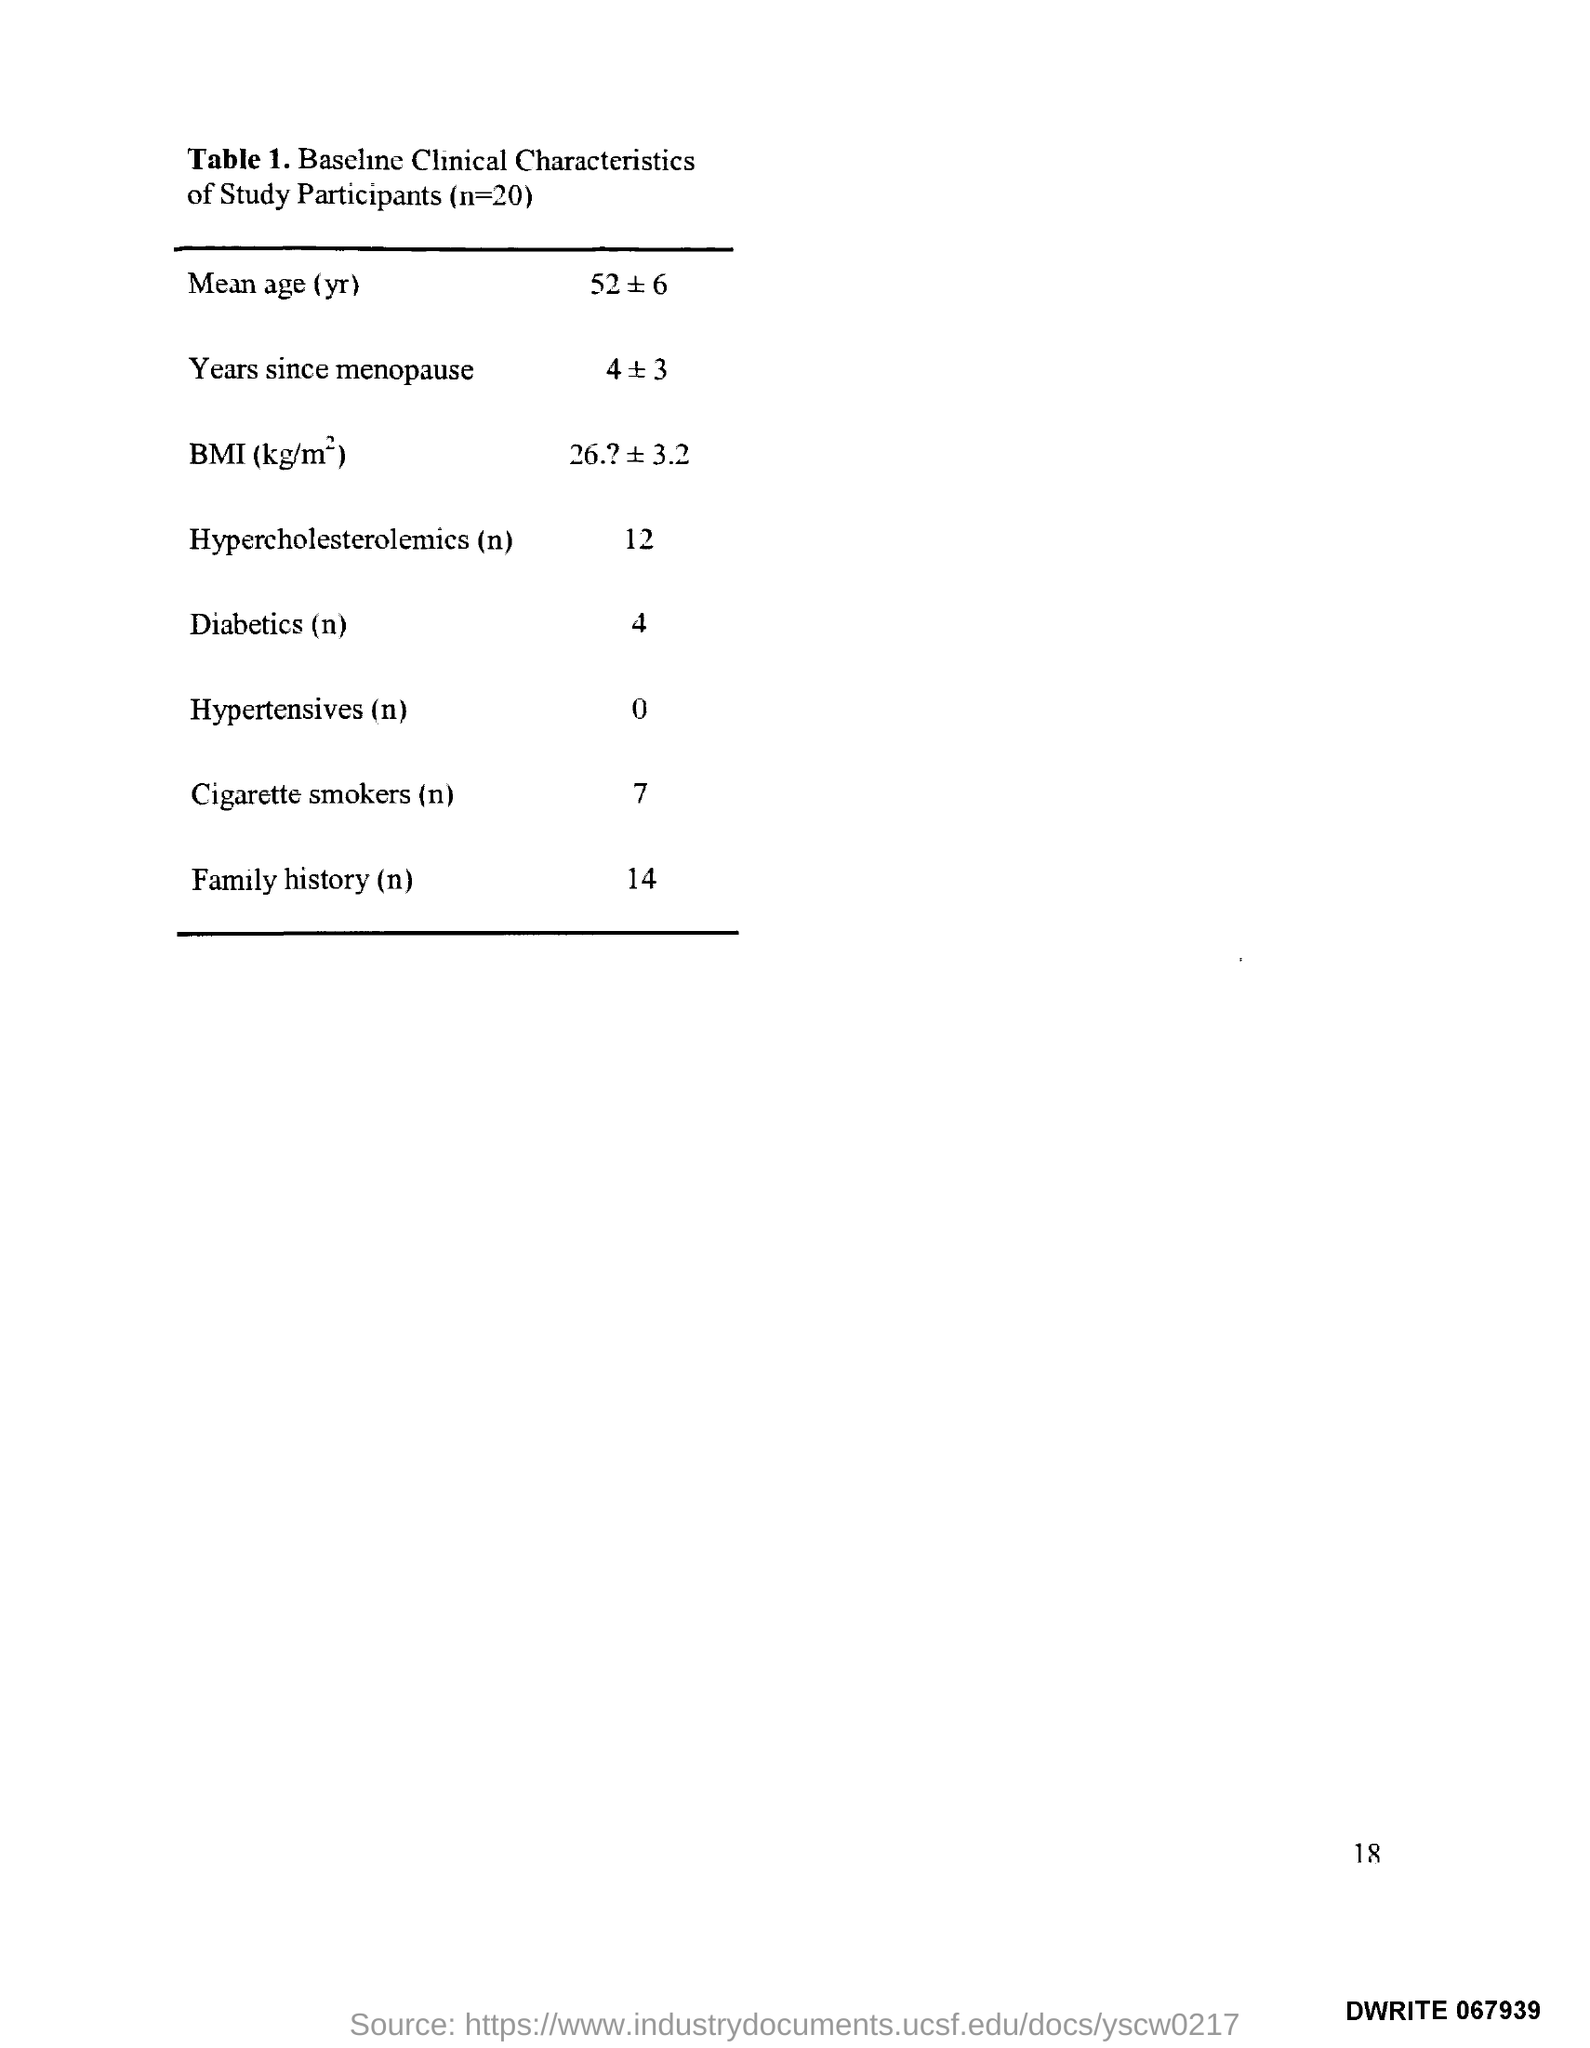What is the Page Number?
Your response must be concise. 18. What is the total number of Participants?
Offer a very short reply. 20. 